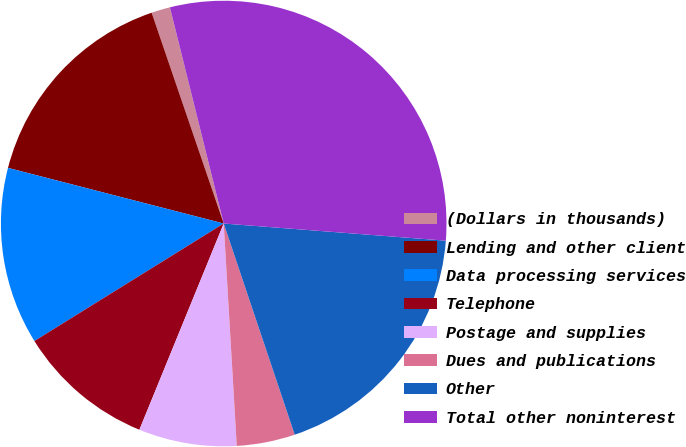<chart> <loc_0><loc_0><loc_500><loc_500><pie_chart><fcel>(Dollars in thousands)<fcel>Lending and other client<fcel>Data processing services<fcel>Telephone<fcel>Postage and supplies<fcel>Dues and publications<fcel>Other<fcel>Total other noninterest<nl><fcel>1.36%<fcel>15.74%<fcel>12.86%<fcel>9.98%<fcel>7.11%<fcel>4.23%<fcel>18.61%<fcel>30.11%<nl></chart> 